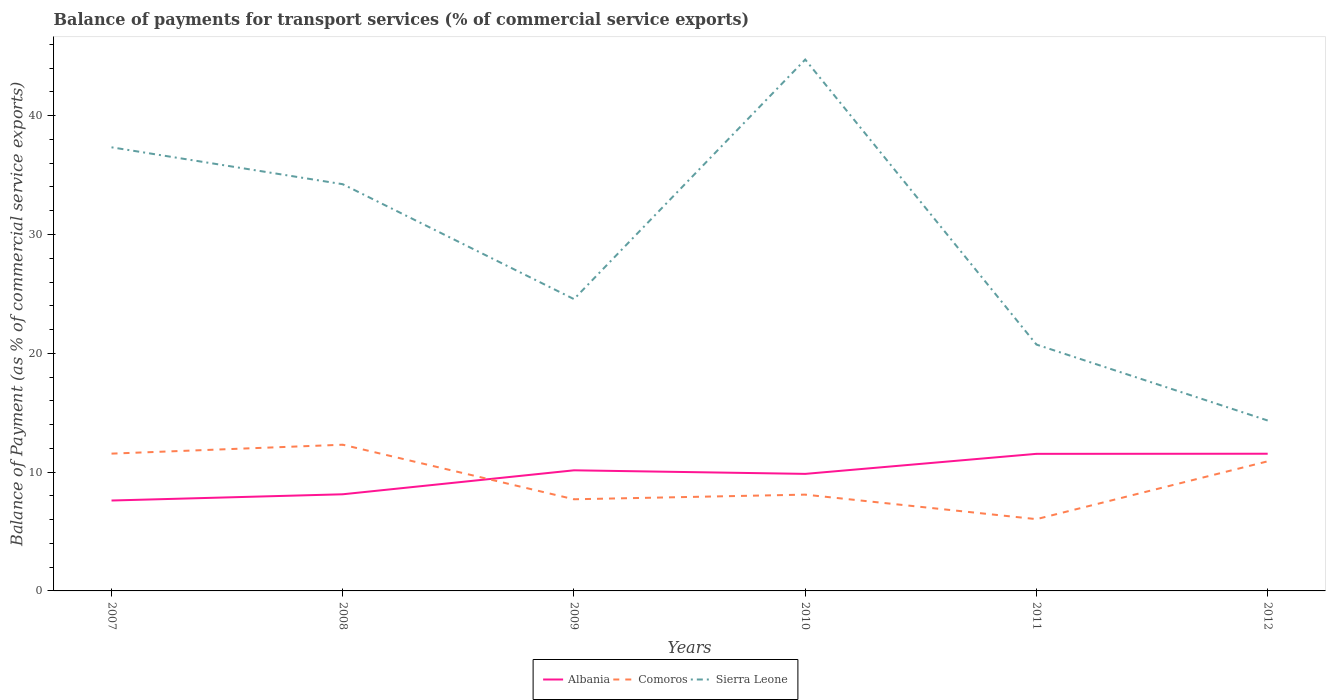Across all years, what is the maximum balance of payments for transport services in Albania?
Offer a terse response. 7.61. What is the total balance of payments for transport services in Comoros in the graph?
Provide a succinct answer. -0.75. What is the difference between the highest and the second highest balance of payments for transport services in Comoros?
Offer a very short reply. 6.26. What is the difference between the highest and the lowest balance of payments for transport services in Albania?
Ensure brevity in your answer.  4. How many years are there in the graph?
Make the answer very short. 6. Does the graph contain any zero values?
Your answer should be very brief. No. Does the graph contain grids?
Offer a terse response. No. Where does the legend appear in the graph?
Provide a succinct answer. Bottom center. What is the title of the graph?
Provide a succinct answer. Balance of payments for transport services (% of commercial service exports). What is the label or title of the Y-axis?
Make the answer very short. Balance of Payment (as % of commercial service exports). What is the Balance of Payment (as % of commercial service exports) of Albania in 2007?
Keep it short and to the point. 7.61. What is the Balance of Payment (as % of commercial service exports) in Comoros in 2007?
Provide a succinct answer. 11.56. What is the Balance of Payment (as % of commercial service exports) of Sierra Leone in 2007?
Provide a succinct answer. 37.34. What is the Balance of Payment (as % of commercial service exports) in Albania in 2008?
Offer a terse response. 8.13. What is the Balance of Payment (as % of commercial service exports) in Comoros in 2008?
Offer a terse response. 12.31. What is the Balance of Payment (as % of commercial service exports) in Sierra Leone in 2008?
Give a very brief answer. 34.23. What is the Balance of Payment (as % of commercial service exports) in Albania in 2009?
Provide a short and direct response. 10.15. What is the Balance of Payment (as % of commercial service exports) of Comoros in 2009?
Make the answer very short. 7.71. What is the Balance of Payment (as % of commercial service exports) in Sierra Leone in 2009?
Your answer should be very brief. 24.56. What is the Balance of Payment (as % of commercial service exports) in Albania in 2010?
Offer a very short reply. 9.85. What is the Balance of Payment (as % of commercial service exports) of Comoros in 2010?
Make the answer very short. 8.1. What is the Balance of Payment (as % of commercial service exports) in Sierra Leone in 2010?
Offer a very short reply. 44.72. What is the Balance of Payment (as % of commercial service exports) in Albania in 2011?
Your answer should be compact. 11.54. What is the Balance of Payment (as % of commercial service exports) of Comoros in 2011?
Offer a terse response. 6.04. What is the Balance of Payment (as % of commercial service exports) of Sierra Leone in 2011?
Provide a succinct answer. 20.73. What is the Balance of Payment (as % of commercial service exports) of Albania in 2012?
Provide a short and direct response. 11.55. What is the Balance of Payment (as % of commercial service exports) of Comoros in 2012?
Offer a terse response. 10.91. What is the Balance of Payment (as % of commercial service exports) of Sierra Leone in 2012?
Provide a short and direct response. 14.34. Across all years, what is the maximum Balance of Payment (as % of commercial service exports) of Albania?
Your response must be concise. 11.55. Across all years, what is the maximum Balance of Payment (as % of commercial service exports) of Comoros?
Provide a succinct answer. 12.31. Across all years, what is the maximum Balance of Payment (as % of commercial service exports) in Sierra Leone?
Offer a terse response. 44.72. Across all years, what is the minimum Balance of Payment (as % of commercial service exports) of Albania?
Offer a terse response. 7.61. Across all years, what is the minimum Balance of Payment (as % of commercial service exports) of Comoros?
Keep it short and to the point. 6.04. Across all years, what is the minimum Balance of Payment (as % of commercial service exports) in Sierra Leone?
Provide a short and direct response. 14.34. What is the total Balance of Payment (as % of commercial service exports) in Albania in the graph?
Make the answer very short. 58.83. What is the total Balance of Payment (as % of commercial service exports) of Comoros in the graph?
Provide a short and direct response. 56.63. What is the total Balance of Payment (as % of commercial service exports) in Sierra Leone in the graph?
Keep it short and to the point. 175.93. What is the difference between the Balance of Payment (as % of commercial service exports) of Albania in 2007 and that in 2008?
Your answer should be compact. -0.53. What is the difference between the Balance of Payment (as % of commercial service exports) of Comoros in 2007 and that in 2008?
Give a very brief answer. -0.75. What is the difference between the Balance of Payment (as % of commercial service exports) of Sierra Leone in 2007 and that in 2008?
Keep it short and to the point. 3.11. What is the difference between the Balance of Payment (as % of commercial service exports) in Albania in 2007 and that in 2009?
Give a very brief answer. -2.54. What is the difference between the Balance of Payment (as % of commercial service exports) in Comoros in 2007 and that in 2009?
Provide a short and direct response. 3.84. What is the difference between the Balance of Payment (as % of commercial service exports) in Sierra Leone in 2007 and that in 2009?
Provide a short and direct response. 12.78. What is the difference between the Balance of Payment (as % of commercial service exports) of Albania in 2007 and that in 2010?
Make the answer very short. -2.24. What is the difference between the Balance of Payment (as % of commercial service exports) of Comoros in 2007 and that in 2010?
Your answer should be very brief. 3.45. What is the difference between the Balance of Payment (as % of commercial service exports) of Sierra Leone in 2007 and that in 2010?
Make the answer very short. -7.39. What is the difference between the Balance of Payment (as % of commercial service exports) in Albania in 2007 and that in 2011?
Offer a terse response. -3.93. What is the difference between the Balance of Payment (as % of commercial service exports) of Comoros in 2007 and that in 2011?
Your answer should be very brief. 5.51. What is the difference between the Balance of Payment (as % of commercial service exports) of Sierra Leone in 2007 and that in 2011?
Provide a succinct answer. 16.6. What is the difference between the Balance of Payment (as % of commercial service exports) in Albania in 2007 and that in 2012?
Ensure brevity in your answer.  -3.94. What is the difference between the Balance of Payment (as % of commercial service exports) of Comoros in 2007 and that in 2012?
Your answer should be very brief. 0.65. What is the difference between the Balance of Payment (as % of commercial service exports) of Sierra Leone in 2007 and that in 2012?
Your answer should be very brief. 23. What is the difference between the Balance of Payment (as % of commercial service exports) in Albania in 2008 and that in 2009?
Provide a succinct answer. -2.02. What is the difference between the Balance of Payment (as % of commercial service exports) of Comoros in 2008 and that in 2009?
Give a very brief answer. 4.59. What is the difference between the Balance of Payment (as % of commercial service exports) of Sierra Leone in 2008 and that in 2009?
Offer a very short reply. 9.67. What is the difference between the Balance of Payment (as % of commercial service exports) of Albania in 2008 and that in 2010?
Offer a terse response. -1.72. What is the difference between the Balance of Payment (as % of commercial service exports) in Comoros in 2008 and that in 2010?
Your answer should be very brief. 4.2. What is the difference between the Balance of Payment (as % of commercial service exports) in Sierra Leone in 2008 and that in 2010?
Offer a very short reply. -10.49. What is the difference between the Balance of Payment (as % of commercial service exports) in Albania in 2008 and that in 2011?
Offer a terse response. -3.4. What is the difference between the Balance of Payment (as % of commercial service exports) in Comoros in 2008 and that in 2011?
Make the answer very short. 6.26. What is the difference between the Balance of Payment (as % of commercial service exports) of Sierra Leone in 2008 and that in 2011?
Keep it short and to the point. 13.5. What is the difference between the Balance of Payment (as % of commercial service exports) of Albania in 2008 and that in 2012?
Provide a short and direct response. -3.41. What is the difference between the Balance of Payment (as % of commercial service exports) in Comoros in 2008 and that in 2012?
Your answer should be compact. 1.4. What is the difference between the Balance of Payment (as % of commercial service exports) in Sierra Leone in 2008 and that in 2012?
Keep it short and to the point. 19.89. What is the difference between the Balance of Payment (as % of commercial service exports) in Albania in 2009 and that in 2010?
Give a very brief answer. 0.3. What is the difference between the Balance of Payment (as % of commercial service exports) of Comoros in 2009 and that in 2010?
Ensure brevity in your answer.  -0.39. What is the difference between the Balance of Payment (as % of commercial service exports) in Sierra Leone in 2009 and that in 2010?
Provide a succinct answer. -20.16. What is the difference between the Balance of Payment (as % of commercial service exports) in Albania in 2009 and that in 2011?
Your response must be concise. -1.39. What is the difference between the Balance of Payment (as % of commercial service exports) of Comoros in 2009 and that in 2011?
Your answer should be very brief. 1.67. What is the difference between the Balance of Payment (as % of commercial service exports) in Sierra Leone in 2009 and that in 2011?
Provide a succinct answer. 3.83. What is the difference between the Balance of Payment (as % of commercial service exports) of Albania in 2009 and that in 2012?
Provide a succinct answer. -1.4. What is the difference between the Balance of Payment (as % of commercial service exports) in Comoros in 2009 and that in 2012?
Offer a very short reply. -3.19. What is the difference between the Balance of Payment (as % of commercial service exports) in Sierra Leone in 2009 and that in 2012?
Make the answer very short. 10.22. What is the difference between the Balance of Payment (as % of commercial service exports) of Albania in 2010 and that in 2011?
Offer a very short reply. -1.69. What is the difference between the Balance of Payment (as % of commercial service exports) in Comoros in 2010 and that in 2011?
Give a very brief answer. 2.06. What is the difference between the Balance of Payment (as % of commercial service exports) in Sierra Leone in 2010 and that in 2011?
Offer a terse response. 23.99. What is the difference between the Balance of Payment (as % of commercial service exports) in Albania in 2010 and that in 2012?
Make the answer very short. -1.7. What is the difference between the Balance of Payment (as % of commercial service exports) of Comoros in 2010 and that in 2012?
Offer a terse response. -2.8. What is the difference between the Balance of Payment (as % of commercial service exports) of Sierra Leone in 2010 and that in 2012?
Your answer should be compact. 30.38. What is the difference between the Balance of Payment (as % of commercial service exports) in Albania in 2011 and that in 2012?
Offer a very short reply. -0.01. What is the difference between the Balance of Payment (as % of commercial service exports) in Comoros in 2011 and that in 2012?
Give a very brief answer. -4.87. What is the difference between the Balance of Payment (as % of commercial service exports) in Sierra Leone in 2011 and that in 2012?
Provide a succinct answer. 6.39. What is the difference between the Balance of Payment (as % of commercial service exports) in Albania in 2007 and the Balance of Payment (as % of commercial service exports) in Comoros in 2008?
Ensure brevity in your answer.  -4.7. What is the difference between the Balance of Payment (as % of commercial service exports) of Albania in 2007 and the Balance of Payment (as % of commercial service exports) of Sierra Leone in 2008?
Offer a very short reply. -26.62. What is the difference between the Balance of Payment (as % of commercial service exports) in Comoros in 2007 and the Balance of Payment (as % of commercial service exports) in Sierra Leone in 2008?
Offer a terse response. -22.68. What is the difference between the Balance of Payment (as % of commercial service exports) in Albania in 2007 and the Balance of Payment (as % of commercial service exports) in Comoros in 2009?
Your answer should be very brief. -0.11. What is the difference between the Balance of Payment (as % of commercial service exports) in Albania in 2007 and the Balance of Payment (as % of commercial service exports) in Sierra Leone in 2009?
Offer a very short reply. -16.95. What is the difference between the Balance of Payment (as % of commercial service exports) of Comoros in 2007 and the Balance of Payment (as % of commercial service exports) of Sierra Leone in 2009?
Offer a very short reply. -13.01. What is the difference between the Balance of Payment (as % of commercial service exports) of Albania in 2007 and the Balance of Payment (as % of commercial service exports) of Comoros in 2010?
Your answer should be very brief. -0.5. What is the difference between the Balance of Payment (as % of commercial service exports) in Albania in 2007 and the Balance of Payment (as % of commercial service exports) in Sierra Leone in 2010?
Give a very brief answer. -37.12. What is the difference between the Balance of Payment (as % of commercial service exports) in Comoros in 2007 and the Balance of Payment (as % of commercial service exports) in Sierra Leone in 2010?
Ensure brevity in your answer.  -33.17. What is the difference between the Balance of Payment (as % of commercial service exports) in Albania in 2007 and the Balance of Payment (as % of commercial service exports) in Comoros in 2011?
Give a very brief answer. 1.57. What is the difference between the Balance of Payment (as % of commercial service exports) in Albania in 2007 and the Balance of Payment (as % of commercial service exports) in Sierra Leone in 2011?
Provide a short and direct response. -13.13. What is the difference between the Balance of Payment (as % of commercial service exports) of Comoros in 2007 and the Balance of Payment (as % of commercial service exports) of Sierra Leone in 2011?
Give a very brief answer. -9.18. What is the difference between the Balance of Payment (as % of commercial service exports) in Albania in 2007 and the Balance of Payment (as % of commercial service exports) in Comoros in 2012?
Make the answer very short. -3.3. What is the difference between the Balance of Payment (as % of commercial service exports) in Albania in 2007 and the Balance of Payment (as % of commercial service exports) in Sierra Leone in 2012?
Offer a terse response. -6.73. What is the difference between the Balance of Payment (as % of commercial service exports) in Comoros in 2007 and the Balance of Payment (as % of commercial service exports) in Sierra Leone in 2012?
Provide a short and direct response. -2.79. What is the difference between the Balance of Payment (as % of commercial service exports) of Albania in 2008 and the Balance of Payment (as % of commercial service exports) of Comoros in 2009?
Provide a short and direct response. 0.42. What is the difference between the Balance of Payment (as % of commercial service exports) of Albania in 2008 and the Balance of Payment (as % of commercial service exports) of Sierra Leone in 2009?
Give a very brief answer. -16.43. What is the difference between the Balance of Payment (as % of commercial service exports) of Comoros in 2008 and the Balance of Payment (as % of commercial service exports) of Sierra Leone in 2009?
Provide a short and direct response. -12.26. What is the difference between the Balance of Payment (as % of commercial service exports) in Albania in 2008 and the Balance of Payment (as % of commercial service exports) in Comoros in 2010?
Make the answer very short. 0.03. What is the difference between the Balance of Payment (as % of commercial service exports) in Albania in 2008 and the Balance of Payment (as % of commercial service exports) in Sierra Leone in 2010?
Your response must be concise. -36.59. What is the difference between the Balance of Payment (as % of commercial service exports) in Comoros in 2008 and the Balance of Payment (as % of commercial service exports) in Sierra Leone in 2010?
Offer a terse response. -32.42. What is the difference between the Balance of Payment (as % of commercial service exports) of Albania in 2008 and the Balance of Payment (as % of commercial service exports) of Comoros in 2011?
Offer a very short reply. 2.09. What is the difference between the Balance of Payment (as % of commercial service exports) in Comoros in 2008 and the Balance of Payment (as % of commercial service exports) in Sierra Leone in 2011?
Your response must be concise. -8.43. What is the difference between the Balance of Payment (as % of commercial service exports) in Albania in 2008 and the Balance of Payment (as % of commercial service exports) in Comoros in 2012?
Make the answer very short. -2.77. What is the difference between the Balance of Payment (as % of commercial service exports) of Albania in 2008 and the Balance of Payment (as % of commercial service exports) of Sierra Leone in 2012?
Offer a terse response. -6.21. What is the difference between the Balance of Payment (as % of commercial service exports) in Comoros in 2008 and the Balance of Payment (as % of commercial service exports) in Sierra Leone in 2012?
Give a very brief answer. -2.04. What is the difference between the Balance of Payment (as % of commercial service exports) of Albania in 2009 and the Balance of Payment (as % of commercial service exports) of Comoros in 2010?
Make the answer very short. 2.05. What is the difference between the Balance of Payment (as % of commercial service exports) of Albania in 2009 and the Balance of Payment (as % of commercial service exports) of Sierra Leone in 2010?
Make the answer very short. -34.57. What is the difference between the Balance of Payment (as % of commercial service exports) in Comoros in 2009 and the Balance of Payment (as % of commercial service exports) in Sierra Leone in 2010?
Provide a short and direct response. -37.01. What is the difference between the Balance of Payment (as % of commercial service exports) in Albania in 2009 and the Balance of Payment (as % of commercial service exports) in Comoros in 2011?
Give a very brief answer. 4.11. What is the difference between the Balance of Payment (as % of commercial service exports) in Albania in 2009 and the Balance of Payment (as % of commercial service exports) in Sierra Leone in 2011?
Ensure brevity in your answer.  -10.58. What is the difference between the Balance of Payment (as % of commercial service exports) of Comoros in 2009 and the Balance of Payment (as % of commercial service exports) of Sierra Leone in 2011?
Provide a succinct answer. -13.02. What is the difference between the Balance of Payment (as % of commercial service exports) in Albania in 2009 and the Balance of Payment (as % of commercial service exports) in Comoros in 2012?
Give a very brief answer. -0.76. What is the difference between the Balance of Payment (as % of commercial service exports) of Albania in 2009 and the Balance of Payment (as % of commercial service exports) of Sierra Leone in 2012?
Your answer should be compact. -4.19. What is the difference between the Balance of Payment (as % of commercial service exports) of Comoros in 2009 and the Balance of Payment (as % of commercial service exports) of Sierra Leone in 2012?
Your answer should be very brief. -6.63. What is the difference between the Balance of Payment (as % of commercial service exports) in Albania in 2010 and the Balance of Payment (as % of commercial service exports) in Comoros in 2011?
Offer a terse response. 3.81. What is the difference between the Balance of Payment (as % of commercial service exports) of Albania in 2010 and the Balance of Payment (as % of commercial service exports) of Sierra Leone in 2011?
Offer a very short reply. -10.88. What is the difference between the Balance of Payment (as % of commercial service exports) in Comoros in 2010 and the Balance of Payment (as % of commercial service exports) in Sierra Leone in 2011?
Offer a terse response. -12.63. What is the difference between the Balance of Payment (as % of commercial service exports) of Albania in 2010 and the Balance of Payment (as % of commercial service exports) of Comoros in 2012?
Make the answer very short. -1.06. What is the difference between the Balance of Payment (as % of commercial service exports) in Albania in 2010 and the Balance of Payment (as % of commercial service exports) in Sierra Leone in 2012?
Offer a terse response. -4.49. What is the difference between the Balance of Payment (as % of commercial service exports) in Comoros in 2010 and the Balance of Payment (as % of commercial service exports) in Sierra Leone in 2012?
Provide a short and direct response. -6.24. What is the difference between the Balance of Payment (as % of commercial service exports) in Albania in 2011 and the Balance of Payment (as % of commercial service exports) in Comoros in 2012?
Give a very brief answer. 0.63. What is the difference between the Balance of Payment (as % of commercial service exports) of Albania in 2011 and the Balance of Payment (as % of commercial service exports) of Sierra Leone in 2012?
Provide a short and direct response. -2.8. What is the difference between the Balance of Payment (as % of commercial service exports) in Comoros in 2011 and the Balance of Payment (as % of commercial service exports) in Sierra Leone in 2012?
Your response must be concise. -8.3. What is the average Balance of Payment (as % of commercial service exports) of Albania per year?
Keep it short and to the point. 9.81. What is the average Balance of Payment (as % of commercial service exports) of Comoros per year?
Ensure brevity in your answer.  9.44. What is the average Balance of Payment (as % of commercial service exports) in Sierra Leone per year?
Offer a very short reply. 29.32. In the year 2007, what is the difference between the Balance of Payment (as % of commercial service exports) in Albania and Balance of Payment (as % of commercial service exports) in Comoros?
Your answer should be compact. -3.95. In the year 2007, what is the difference between the Balance of Payment (as % of commercial service exports) in Albania and Balance of Payment (as % of commercial service exports) in Sierra Leone?
Provide a succinct answer. -29.73. In the year 2007, what is the difference between the Balance of Payment (as % of commercial service exports) in Comoros and Balance of Payment (as % of commercial service exports) in Sierra Leone?
Offer a terse response. -25.78. In the year 2008, what is the difference between the Balance of Payment (as % of commercial service exports) in Albania and Balance of Payment (as % of commercial service exports) in Comoros?
Offer a very short reply. -4.17. In the year 2008, what is the difference between the Balance of Payment (as % of commercial service exports) in Albania and Balance of Payment (as % of commercial service exports) in Sierra Leone?
Provide a succinct answer. -26.1. In the year 2008, what is the difference between the Balance of Payment (as % of commercial service exports) in Comoros and Balance of Payment (as % of commercial service exports) in Sierra Leone?
Provide a succinct answer. -21.93. In the year 2009, what is the difference between the Balance of Payment (as % of commercial service exports) in Albania and Balance of Payment (as % of commercial service exports) in Comoros?
Offer a terse response. 2.44. In the year 2009, what is the difference between the Balance of Payment (as % of commercial service exports) in Albania and Balance of Payment (as % of commercial service exports) in Sierra Leone?
Give a very brief answer. -14.41. In the year 2009, what is the difference between the Balance of Payment (as % of commercial service exports) of Comoros and Balance of Payment (as % of commercial service exports) of Sierra Leone?
Your answer should be compact. -16.85. In the year 2010, what is the difference between the Balance of Payment (as % of commercial service exports) in Albania and Balance of Payment (as % of commercial service exports) in Comoros?
Make the answer very short. 1.75. In the year 2010, what is the difference between the Balance of Payment (as % of commercial service exports) of Albania and Balance of Payment (as % of commercial service exports) of Sierra Leone?
Your answer should be very brief. -34.87. In the year 2010, what is the difference between the Balance of Payment (as % of commercial service exports) of Comoros and Balance of Payment (as % of commercial service exports) of Sierra Leone?
Provide a succinct answer. -36.62. In the year 2011, what is the difference between the Balance of Payment (as % of commercial service exports) in Albania and Balance of Payment (as % of commercial service exports) in Comoros?
Provide a succinct answer. 5.5. In the year 2011, what is the difference between the Balance of Payment (as % of commercial service exports) in Albania and Balance of Payment (as % of commercial service exports) in Sierra Leone?
Provide a succinct answer. -9.2. In the year 2011, what is the difference between the Balance of Payment (as % of commercial service exports) in Comoros and Balance of Payment (as % of commercial service exports) in Sierra Leone?
Make the answer very short. -14.69. In the year 2012, what is the difference between the Balance of Payment (as % of commercial service exports) in Albania and Balance of Payment (as % of commercial service exports) in Comoros?
Make the answer very short. 0.64. In the year 2012, what is the difference between the Balance of Payment (as % of commercial service exports) of Albania and Balance of Payment (as % of commercial service exports) of Sierra Leone?
Ensure brevity in your answer.  -2.8. In the year 2012, what is the difference between the Balance of Payment (as % of commercial service exports) in Comoros and Balance of Payment (as % of commercial service exports) in Sierra Leone?
Ensure brevity in your answer.  -3.43. What is the ratio of the Balance of Payment (as % of commercial service exports) of Albania in 2007 to that in 2008?
Provide a succinct answer. 0.94. What is the ratio of the Balance of Payment (as % of commercial service exports) in Comoros in 2007 to that in 2008?
Make the answer very short. 0.94. What is the ratio of the Balance of Payment (as % of commercial service exports) in Sierra Leone in 2007 to that in 2008?
Offer a very short reply. 1.09. What is the ratio of the Balance of Payment (as % of commercial service exports) in Albania in 2007 to that in 2009?
Your answer should be compact. 0.75. What is the ratio of the Balance of Payment (as % of commercial service exports) of Comoros in 2007 to that in 2009?
Make the answer very short. 1.5. What is the ratio of the Balance of Payment (as % of commercial service exports) in Sierra Leone in 2007 to that in 2009?
Keep it short and to the point. 1.52. What is the ratio of the Balance of Payment (as % of commercial service exports) of Albania in 2007 to that in 2010?
Make the answer very short. 0.77. What is the ratio of the Balance of Payment (as % of commercial service exports) of Comoros in 2007 to that in 2010?
Make the answer very short. 1.43. What is the ratio of the Balance of Payment (as % of commercial service exports) in Sierra Leone in 2007 to that in 2010?
Provide a short and direct response. 0.83. What is the ratio of the Balance of Payment (as % of commercial service exports) in Albania in 2007 to that in 2011?
Make the answer very short. 0.66. What is the ratio of the Balance of Payment (as % of commercial service exports) of Comoros in 2007 to that in 2011?
Your answer should be very brief. 1.91. What is the ratio of the Balance of Payment (as % of commercial service exports) in Sierra Leone in 2007 to that in 2011?
Provide a short and direct response. 1.8. What is the ratio of the Balance of Payment (as % of commercial service exports) in Albania in 2007 to that in 2012?
Make the answer very short. 0.66. What is the ratio of the Balance of Payment (as % of commercial service exports) in Comoros in 2007 to that in 2012?
Offer a terse response. 1.06. What is the ratio of the Balance of Payment (as % of commercial service exports) of Sierra Leone in 2007 to that in 2012?
Provide a short and direct response. 2.6. What is the ratio of the Balance of Payment (as % of commercial service exports) of Albania in 2008 to that in 2009?
Give a very brief answer. 0.8. What is the ratio of the Balance of Payment (as % of commercial service exports) of Comoros in 2008 to that in 2009?
Your answer should be very brief. 1.6. What is the ratio of the Balance of Payment (as % of commercial service exports) of Sierra Leone in 2008 to that in 2009?
Give a very brief answer. 1.39. What is the ratio of the Balance of Payment (as % of commercial service exports) of Albania in 2008 to that in 2010?
Make the answer very short. 0.83. What is the ratio of the Balance of Payment (as % of commercial service exports) of Comoros in 2008 to that in 2010?
Keep it short and to the point. 1.52. What is the ratio of the Balance of Payment (as % of commercial service exports) of Sierra Leone in 2008 to that in 2010?
Provide a short and direct response. 0.77. What is the ratio of the Balance of Payment (as % of commercial service exports) in Albania in 2008 to that in 2011?
Provide a succinct answer. 0.7. What is the ratio of the Balance of Payment (as % of commercial service exports) of Comoros in 2008 to that in 2011?
Your answer should be compact. 2.04. What is the ratio of the Balance of Payment (as % of commercial service exports) of Sierra Leone in 2008 to that in 2011?
Offer a terse response. 1.65. What is the ratio of the Balance of Payment (as % of commercial service exports) of Albania in 2008 to that in 2012?
Your answer should be compact. 0.7. What is the ratio of the Balance of Payment (as % of commercial service exports) of Comoros in 2008 to that in 2012?
Offer a very short reply. 1.13. What is the ratio of the Balance of Payment (as % of commercial service exports) of Sierra Leone in 2008 to that in 2012?
Give a very brief answer. 2.39. What is the ratio of the Balance of Payment (as % of commercial service exports) of Albania in 2009 to that in 2010?
Ensure brevity in your answer.  1.03. What is the ratio of the Balance of Payment (as % of commercial service exports) of Comoros in 2009 to that in 2010?
Provide a short and direct response. 0.95. What is the ratio of the Balance of Payment (as % of commercial service exports) of Sierra Leone in 2009 to that in 2010?
Ensure brevity in your answer.  0.55. What is the ratio of the Balance of Payment (as % of commercial service exports) in Albania in 2009 to that in 2011?
Your response must be concise. 0.88. What is the ratio of the Balance of Payment (as % of commercial service exports) in Comoros in 2009 to that in 2011?
Offer a terse response. 1.28. What is the ratio of the Balance of Payment (as % of commercial service exports) of Sierra Leone in 2009 to that in 2011?
Provide a succinct answer. 1.18. What is the ratio of the Balance of Payment (as % of commercial service exports) of Albania in 2009 to that in 2012?
Offer a terse response. 0.88. What is the ratio of the Balance of Payment (as % of commercial service exports) in Comoros in 2009 to that in 2012?
Give a very brief answer. 0.71. What is the ratio of the Balance of Payment (as % of commercial service exports) of Sierra Leone in 2009 to that in 2012?
Your answer should be compact. 1.71. What is the ratio of the Balance of Payment (as % of commercial service exports) of Albania in 2010 to that in 2011?
Offer a terse response. 0.85. What is the ratio of the Balance of Payment (as % of commercial service exports) of Comoros in 2010 to that in 2011?
Ensure brevity in your answer.  1.34. What is the ratio of the Balance of Payment (as % of commercial service exports) in Sierra Leone in 2010 to that in 2011?
Your response must be concise. 2.16. What is the ratio of the Balance of Payment (as % of commercial service exports) of Albania in 2010 to that in 2012?
Provide a succinct answer. 0.85. What is the ratio of the Balance of Payment (as % of commercial service exports) in Comoros in 2010 to that in 2012?
Offer a very short reply. 0.74. What is the ratio of the Balance of Payment (as % of commercial service exports) in Sierra Leone in 2010 to that in 2012?
Provide a succinct answer. 3.12. What is the ratio of the Balance of Payment (as % of commercial service exports) in Albania in 2011 to that in 2012?
Offer a terse response. 1. What is the ratio of the Balance of Payment (as % of commercial service exports) of Comoros in 2011 to that in 2012?
Offer a very short reply. 0.55. What is the ratio of the Balance of Payment (as % of commercial service exports) in Sierra Leone in 2011 to that in 2012?
Your response must be concise. 1.45. What is the difference between the highest and the second highest Balance of Payment (as % of commercial service exports) in Albania?
Keep it short and to the point. 0.01. What is the difference between the highest and the second highest Balance of Payment (as % of commercial service exports) of Comoros?
Your answer should be very brief. 0.75. What is the difference between the highest and the second highest Balance of Payment (as % of commercial service exports) in Sierra Leone?
Your answer should be very brief. 7.39. What is the difference between the highest and the lowest Balance of Payment (as % of commercial service exports) of Albania?
Ensure brevity in your answer.  3.94. What is the difference between the highest and the lowest Balance of Payment (as % of commercial service exports) of Comoros?
Make the answer very short. 6.26. What is the difference between the highest and the lowest Balance of Payment (as % of commercial service exports) of Sierra Leone?
Keep it short and to the point. 30.38. 